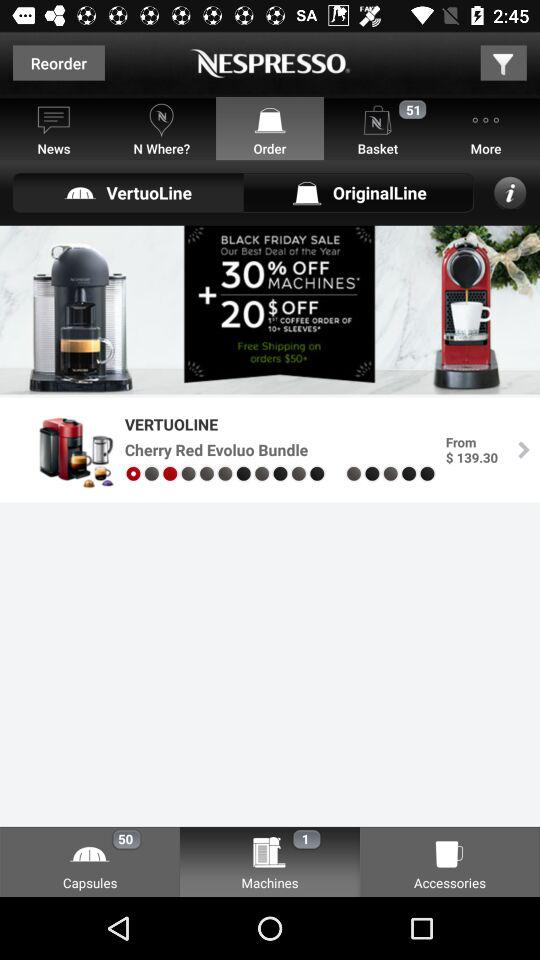How many products are there in the 'Capsules' section?
Answer the question using a single word or phrase. 50 